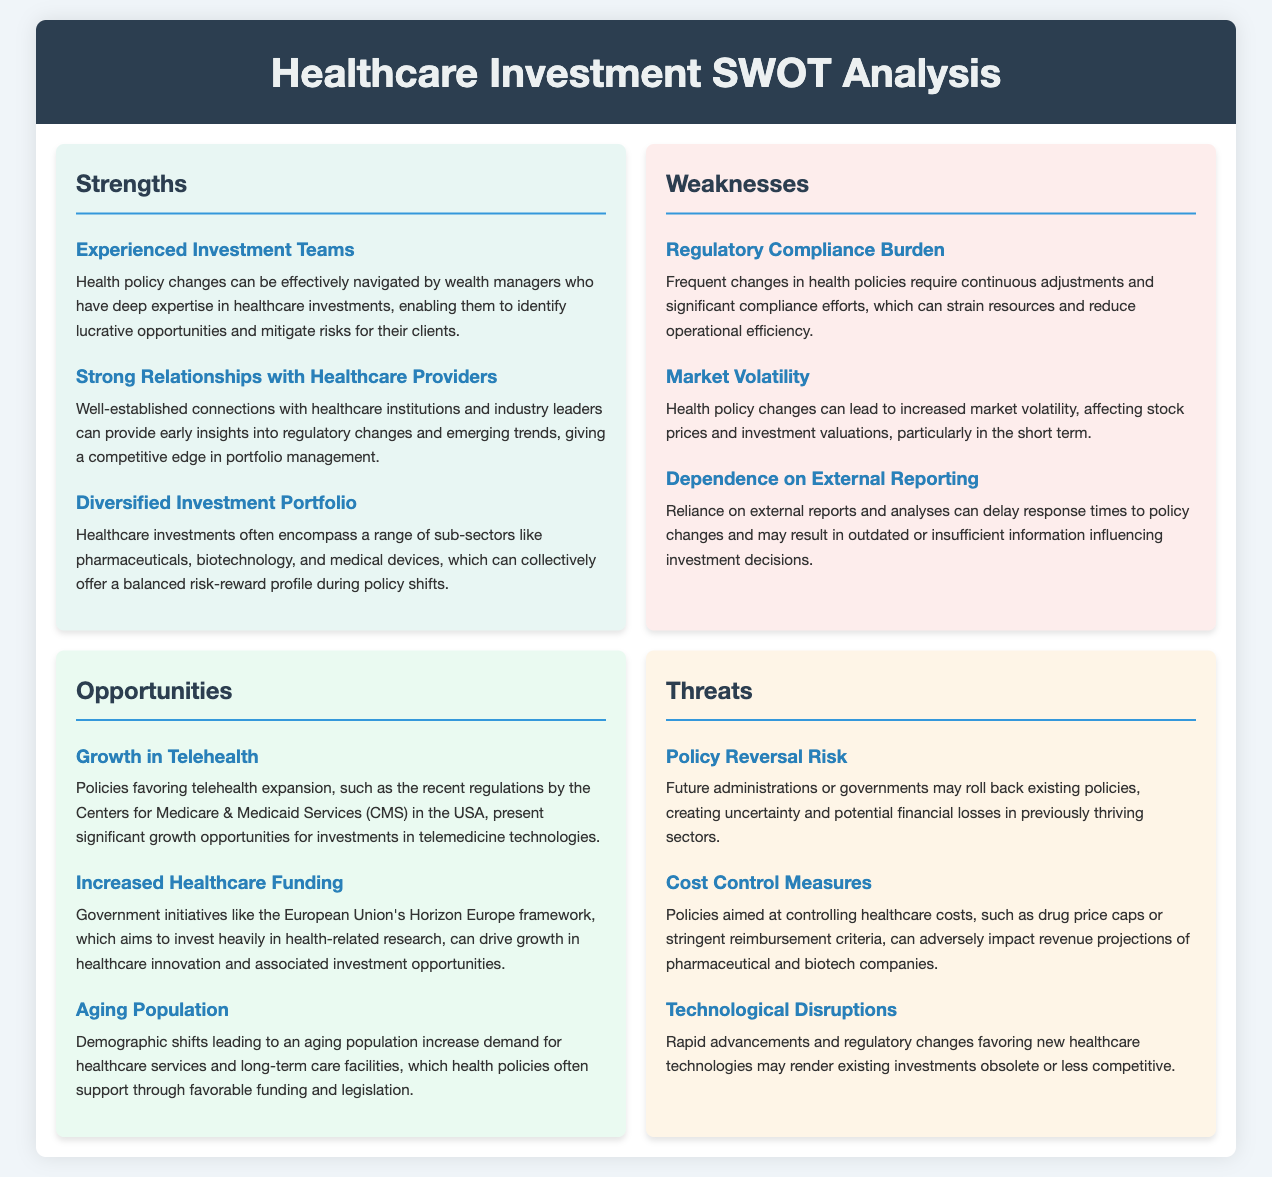What are the strengths mentioned in the analysis? The strengths are the specific elements that highlight the advantages in the context of healthcare investments, including the experienced investment teams, strong relationships with healthcare providers, and diversified investment portfolio.
Answer: Experienced Investment Teams, Strong Relationships with Healthcare Providers, Diversified Investment Portfolio What is a noted weakness related to compliance? The weakness highlights the challenges faced due to the ongoing changes in health policies, impacting operational efficiency; specifically, it refers to the regulatory compliance burden.
Answer: Regulatory Compliance Burden What opportunity is associated with demographic shifts? The opportunity focuses on the increasing demand for healthcare services driven by an aging population, which is directly related to health policies supporting these developments.
Answer: Aging Population What threats arise from potential policy reversals? This threat indicates the risk associated with possible future changes in administration that could reverse existing health policies, affecting financial stability in certain sectors.
Answer: Policy Reversal Risk How many major sections are identified in the SWOT analysis? The sections categorize the analysis and their content accordingly; in this case, there are four major sections identified in the SWOT analysis.
Answer: Four What is the impact of market volatility mentioned in the weaknesses? This weakness discusses how health policy changes can contribute to market fluctuations impacting investment valuations, particularly in the short term.
Answer: Market Volatility Which recent policy is noted as an opportunity for telehealth? This opportunity specifically references regulations from the Centers for Medicare & Medicaid Services in the USA, emphasizing the favorable policies supporting telehealth expansion.
Answer: Centers for Medicare & Medicaid Services (CMS) What industry trend is highlighted as a strength in the analysis? Highlighting a particular advantage, this strength points to the established relationships with healthcare providers and industry leaders that can provide insights into regulatory developments.
Answer: Strong Relationships with Healthcare Providers 